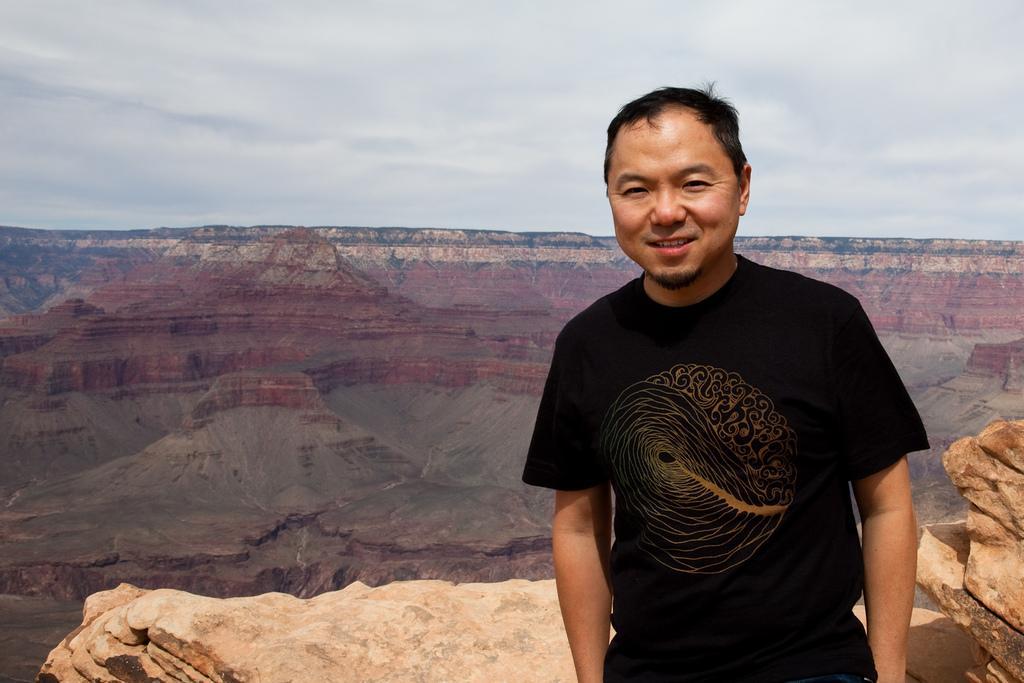Can you describe this image briefly? In this image on the right, there is a man, he wears a t shirt, trouser, he is smiling. In the background there are hills, stones, sky and clouds. 